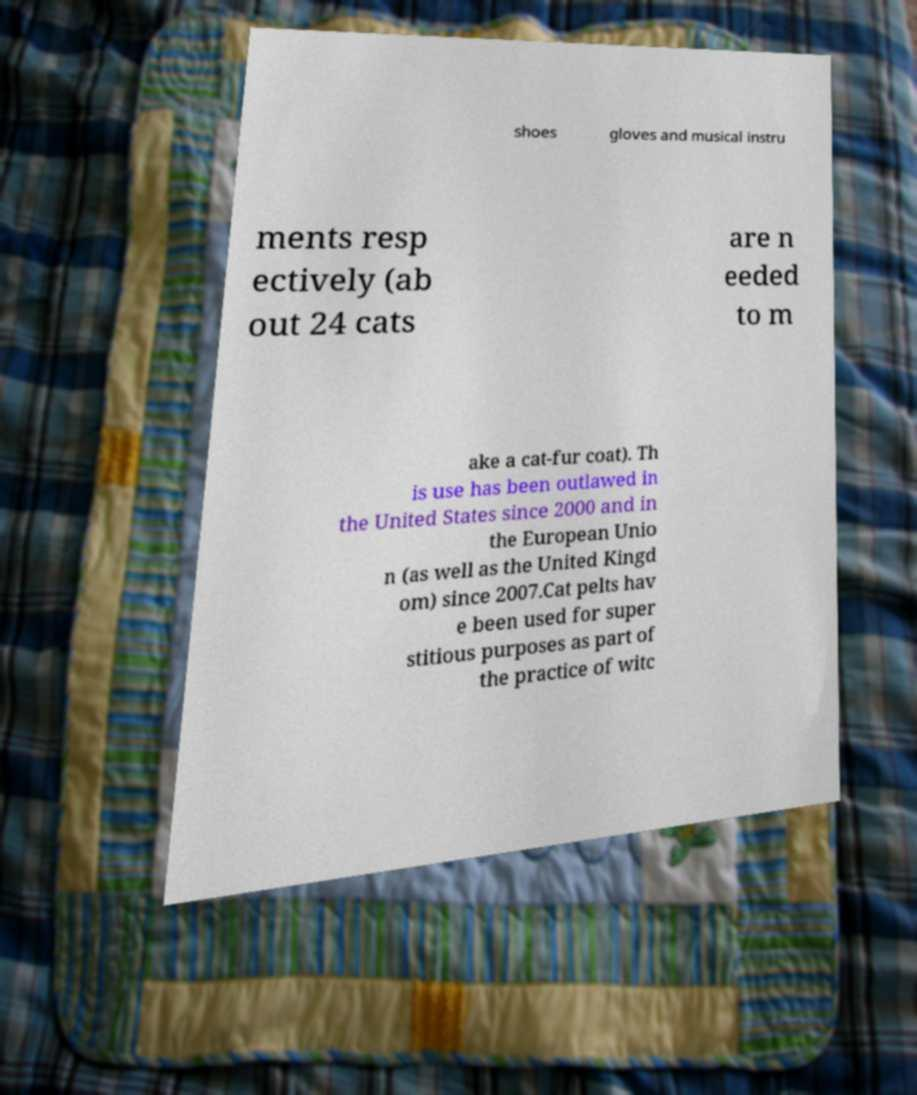I need the written content from this picture converted into text. Can you do that? shoes gloves and musical instru ments resp ectively (ab out 24 cats are n eeded to m ake a cat-fur coat). Th is use has been outlawed in the United States since 2000 and in the European Unio n (as well as the United Kingd om) since 2007.Cat pelts hav e been used for super stitious purposes as part of the practice of witc 